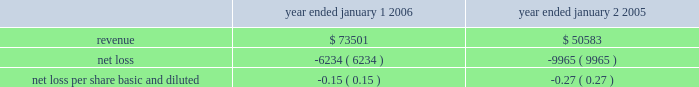In accordance with sfas no .
142 , goodwill and other intangible assets , the goodwill is not amortized , but will be subject to a periodic assessment for impairment by applying a fair-value-based test .
None of this goodwill is expected to be deductible for tax purposes .
The company performs its annual test for impairment of goodwill in may of each year .
The company is required to perform a periodic assessment between annual tests in certain circumstances .
The company has performed its annual test of goodwill as of may 1 , 2006 and has determined there was no impairment of goodwill during 2006 .
The company allocated $ 15.8 million of the purchase price to in-process research and development projects .
In-process research and development ( ipr&d ) represents the valuation of acquired , to-be- completed research projects .
At the acquisition date , cyvera 2019s ongoing research and development initiatives were primarily involved with the development of its veracode technology and the beadxpress reader .
These two projects were approximately 50% ( 50 % ) and 25% ( 25 % ) complete at the date of acquisition , respectively .
As of december 31 , 2006 , these two projects were approximately 90% ( 90 % ) and 80% ( 80 % ) complete , respectively .
The value assigned to purchased ipr&d was determined by estimating the costs to develop the acquired technology into commercially viable products , estimating the resulting net cash flows from the projects , and discounting the net cash flows to their present value .
The revenue projections used to value the ipr&d were , in some cases , reduced based on the probability of developing a new technology , and considered the relevant market sizes and growth factors , expected trends in technology , and the nature and expected timing of new product introductions by the company and its competitors .
The resulting net cash flows from such projects are based on the company 2019s estimates of cost of sales , operating expenses , and income taxes from such projects .
The rates utilized to discount the net cash flows to their present value were based on estimated cost of capital calculations .
Due to the nature of the forecast and the risks associated with the projected growth and profitability of the developmental projects , discount rates of 30% ( 30 % ) were considered appropriate for the ipr&d .
The company believes that these discount rates were commensurate with the projects 2019stage of development and the uncertainties in the economic estimates described above .
If these projects are not successfully developed , the sales and profitability of the combined company may be adversely affected in future periods .
The company believes that the foregoing assumptions used in the ipr&d analysis were reasonable at the time of the acquisition .
No assurance can be given , however , that the underlying assumptions used to estimate expected project sales , development costs or profitability , or the events associated with such projects , will transpire as estimated .
At the date of acquisition , the development of these projects had not yet reached technological feasibility , and the research and development in progress had no alternative future uses .
Accordingly , these costs were charged to expense in the second quarter of 2005 .
The following unaudited pro forma information shows the results of the company 2019s operations for the years ended january 1 , 2006 and january 2 , 2005 as though the acquisition had occurred as of the beginning of the periods presented ( in thousands , except per share data ) : year ended january 1 , year ended january 2 .
Illumina , inc .
Notes to consolidated financial statements 2014 ( continued ) .
What was the percentage change in revenues between 2005 and 2006? 
Computations: ((73501 - 50583) / 50583)
Answer: 0.45308. 